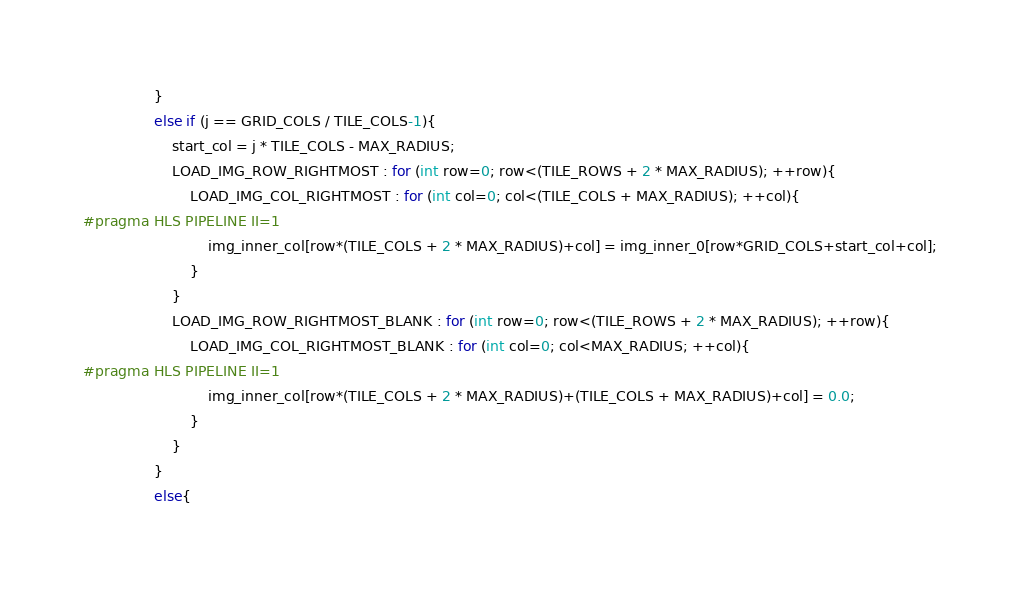<code> <loc_0><loc_0><loc_500><loc_500><_C++_>				}
				else if (j == GRID_COLS / TILE_COLS-1){
					start_col = j * TILE_COLS - MAX_RADIUS;
					LOAD_IMG_ROW_RIGHTMOST : for (int row=0; row<(TILE_ROWS + 2 * MAX_RADIUS); ++row){
						LOAD_IMG_COL_RIGHTMOST : for (int col=0; col<(TILE_COLS + MAX_RADIUS); ++col){
#pragma HLS PIPELINE II=1
							img_inner_col[row*(TILE_COLS + 2 * MAX_RADIUS)+col] = img_inner_0[row*GRID_COLS+start_col+col];
						}
					}
					LOAD_IMG_ROW_RIGHTMOST_BLANK : for (int row=0; row<(TILE_ROWS + 2 * MAX_RADIUS); ++row){
						LOAD_IMG_COL_RIGHTMOST_BLANK : for (int col=0; col<MAX_RADIUS; ++col){
#pragma HLS PIPELINE II=1
							img_inner_col[row*(TILE_COLS + 2 * MAX_RADIUS)+(TILE_COLS + MAX_RADIUS)+col] = 0.0;
						}
					}
				}
				else{</code> 